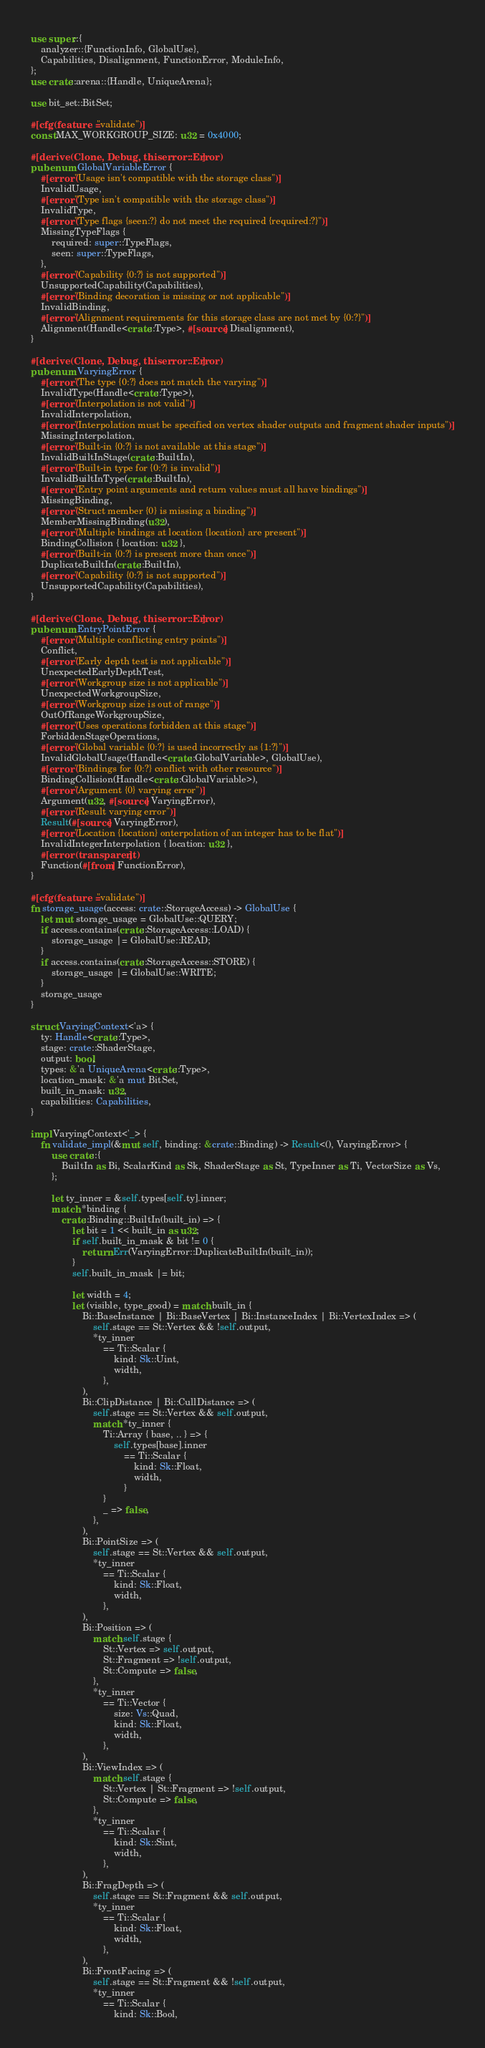<code> <loc_0><loc_0><loc_500><loc_500><_Rust_>use super::{
    analyzer::{FunctionInfo, GlobalUse},
    Capabilities, Disalignment, FunctionError, ModuleInfo,
};
use crate::arena::{Handle, UniqueArena};

use bit_set::BitSet;

#[cfg(feature = "validate")]
const MAX_WORKGROUP_SIZE: u32 = 0x4000;

#[derive(Clone, Debug, thiserror::Error)]
pub enum GlobalVariableError {
    #[error("Usage isn't compatible with the storage class")]
    InvalidUsage,
    #[error("Type isn't compatible with the storage class")]
    InvalidType,
    #[error("Type flags {seen:?} do not meet the required {required:?}")]
    MissingTypeFlags {
        required: super::TypeFlags,
        seen: super::TypeFlags,
    },
    #[error("Capability {0:?} is not supported")]
    UnsupportedCapability(Capabilities),
    #[error("Binding decoration is missing or not applicable")]
    InvalidBinding,
    #[error("Alignment requirements for this storage class are not met by {0:?}")]
    Alignment(Handle<crate::Type>, #[source] Disalignment),
}

#[derive(Clone, Debug, thiserror::Error)]
pub enum VaryingError {
    #[error("The type {0:?} does not match the varying")]
    InvalidType(Handle<crate::Type>),
    #[error("Interpolation is not valid")]
    InvalidInterpolation,
    #[error("Interpolation must be specified on vertex shader outputs and fragment shader inputs")]
    MissingInterpolation,
    #[error("Built-in {0:?} is not available at this stage")]
    InvalidBuiltInStage(crate::BuiltIn),
    #[error("Built-in type for {0:?} is invalid")]
    InvalidBuiltInType(crate::BuiltIn),
    #[error("Entry point arguments and return values must all have bindings")]
    MissingBinding,
    #[error("Struct member {0} is missing a binding")]
    MemberMissingBinding(u32),
    #[error("Multiple bindings at location {location} are present")]
    BindingCollision { location: u32 },
    #[error("Built-in {0:?} is present more than once")]
    DuplicateBuiltIn(crate::BuiltIn),
    #[error("Capability {0:?} is not supported")]
    UnsupportedCapability(Capabilities),
}

#[derive(Clone, Debug, thiserror::Error)]
pub enum EntryPointError {
    #[error("Multiple conflicting entry points")]
    Conflict,
    #[error("Early depth test is not applicable")]
    UnexpectedEarlyDepthTest,
    #[error("Workgroup size is not applicable")]
    UnexpectedWorkgroupSize,
    #[error("Workgroup size is out of range")]
    OutOfRangeWorkgroupSize,
    #[error("Uses operations forbidden at this stage")]
    ForbiddenStageOperations,
    #[error("Global variable {0:?} is used incorrectly as {1:?}")]
    InvalidGlobalUsage(Handle<crate::GlobalVariable>, GlobalUse),
    #[error("Bindings for {0:?} conflict with other resource")]
    BindingCollision(Handle<crate::GlobalVariable>),
    #[error("Argument {0} varying error")]
    Argument(u32, #[source] VaryingError),
    #[error("Result varying error")]
    Result(#[source] VaryingError),
    #[error("Location {location} onterpolation of an integer has to be flat")]
    InvalidIntegerInterpolation { location: u32 },
    #[error(transparent)]
    Function(#[from] FunctionError),
}

#[cfg(feature = "validate")]
fn storage_usage(access: crate::StorageAccess) -> GlobalUse {
    let mut storage_usage = GlobalUse::QUERY;
    if access.contains(crate::StorageAccess::LOAD) {
        storage_usage |= GlobalUse::READ;
    }
    if access.contains(crate::StorageAccess::STORE) {
        storage_usage |= GlobalUse::WRITE;
    }
    storage_usage
}

struct VaryingContext<'a> {
    ty: Handle<crate::Type>,
    stage: crate::ShaderStage,
    output: bool,
    types: &'a UniqueArena<crate::Type>,
    location_mask: &'a mut BitSet,
    built_in_mask: u32,
    capabilities: Capabilities,
}

impl VaryingContext<'_> {
    fn validate_impl(&mut self, binding: &crate::Binding) -> Result<(), VaryingError> {
        use crate::{
            BuiltIn as Bi, ScalarKind as Sk, ShaderStage as St, TypeInner as Ti, VectorSize as Vs,
        };

        let ty_inner = &self.types[self.ty].inner;
        match *binding {
            crate::Binding::BuiltIn(built_in) => {
                let bit = 1 << built_in as u32;
                if self.built_in_mask & bit != 0 {
                    return Err(VaryingError::DuplicateBuiltIn(built_in));
                }
                self.built_in_mask |= bit;

                let width = 4;
                let (visible, type_good) = match built_in {
                    Bi::BaseInstance | Bi::BaseVertex | Bi::InstanceIndex | Bi::VertexIndex => (
                        self.stage == St::Vertex && !self.output,
                        *ty_inner
                            == Ti::Scalar {
                                kind: Sk::Uint,
                                width,
                            },
                    ),
                    Bi::ClipDistance | Bi::CullDistance => (
                        self.stage == St::Vertex && self.output,
                        match *ty_inner {
                            Ti::Array { base, .. } => {
                                self.types[base].inner
                                    == Ti::Scalar {
                                        kind: Sk::Float,
                                        width,
                                    }
                            }
                            _ => false,
                        },
                    ),
                    Bi::PointSize => (
                        self.stage == St::Vertex && self.output,
                        *ty_inner
                            == Ti::Scalar {
                                kind: Sk::Float,
                                width,
                            },
                    ),
                    Bi::Position => (
                        match self.stage {
                            St::Vertex => self.output,
                            St::Fragment => !self.output,
                            St::Compute => false,
                        },
                        *ty_inner
                            == Ti::Vector {
                                size: Vs::Quad,
                                kind: Sk::Float,
                                width,
                            },
                    ),
                    Bi::ViewIndex => (
                        match self.stage {
                            St::Vertex | St::Fragment => !self.output,
                            St::Compute => false,
                        },
                        *ty_inner
                            == Ti::Scalar {
                                kind: Sk::Sint,
                                width,
                            },
                    ),
                    Bi::FragDepth => (
                        self.stage == St::Fragment && self.output,
                        *ty_inner
                            == Ti::Scalar {
                                kind: Sk::Float,
                                width,
                            },
                    ),
                    Bi::FrontFacing => (
                        self.stage == St::Fragment && !self.output,
                        *ty_inner
                            == Ti::Scalar {
                                kind: Sk::Bool,</code> 